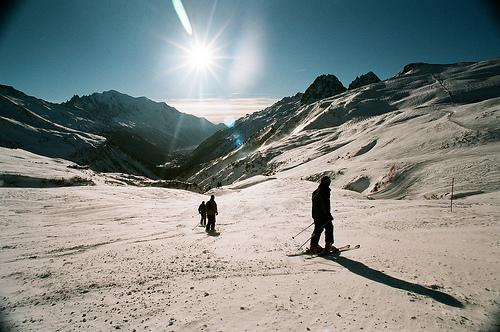Question: what is the very bright star-shaped thing?
Choices:
A. A Christmas decoration.
B. The top of the Christmas tree.
C. The sun.
D. The light.
Answer with the letter. Answer: C Question: when was this picture taken?
Choices:
A. At night.
B. During the day.
C. In the afternoon.
D. In the morning.
Answer with the letter. Answer: B Question: how many people are visible?
Choices:
A. Three.
B. One.
C. Two.
D. Four.
Answer with the letter. Answer: A Question: where these people?
Choices:
A. In a field of flowers.
B. In a snowy forest.
C. On a snowy mountain.
D. On a beach.
Answer with the letter. Answer: C Question: what are these people doing?
Choices:
A. Skating.
B. Skiing.
C. Hiking.
D. Walking.
Answer with the letter. Answer: B Question: what are the things these people are holding?
Choices:
A. Ski sticks.
B. Skates.
C. Snowboard.
D. Skis.
Answer with the letter. Answer: A Question: what color are these people showing as?
Choices:
A. Beige.
B. Tan.
C. White.
D. Black.
Answer with the letter. Answer: D 